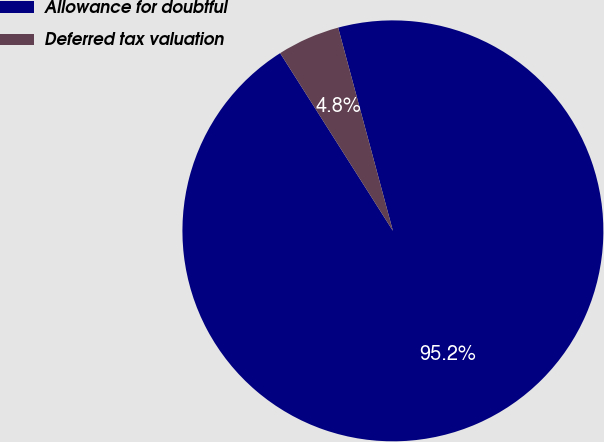Convert chart. <chart><loc_0><loc_0><loc_500><loc_500><pie_chart><fcel>Allowance for doubtful<fcel>Deferred tax valuation<nl><fcel>95.19%<fcel>4.81%<nl></chart> 